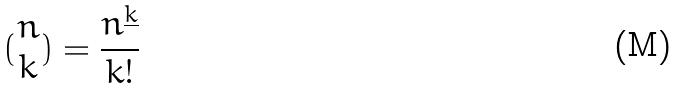<formula> <loc_0><loc_0><loc_500><loc_500>( \begin{matrix} n \\ k \end{matrix} ) = \frac { n ^ { \underline { k } } } { k ! }</formula> 